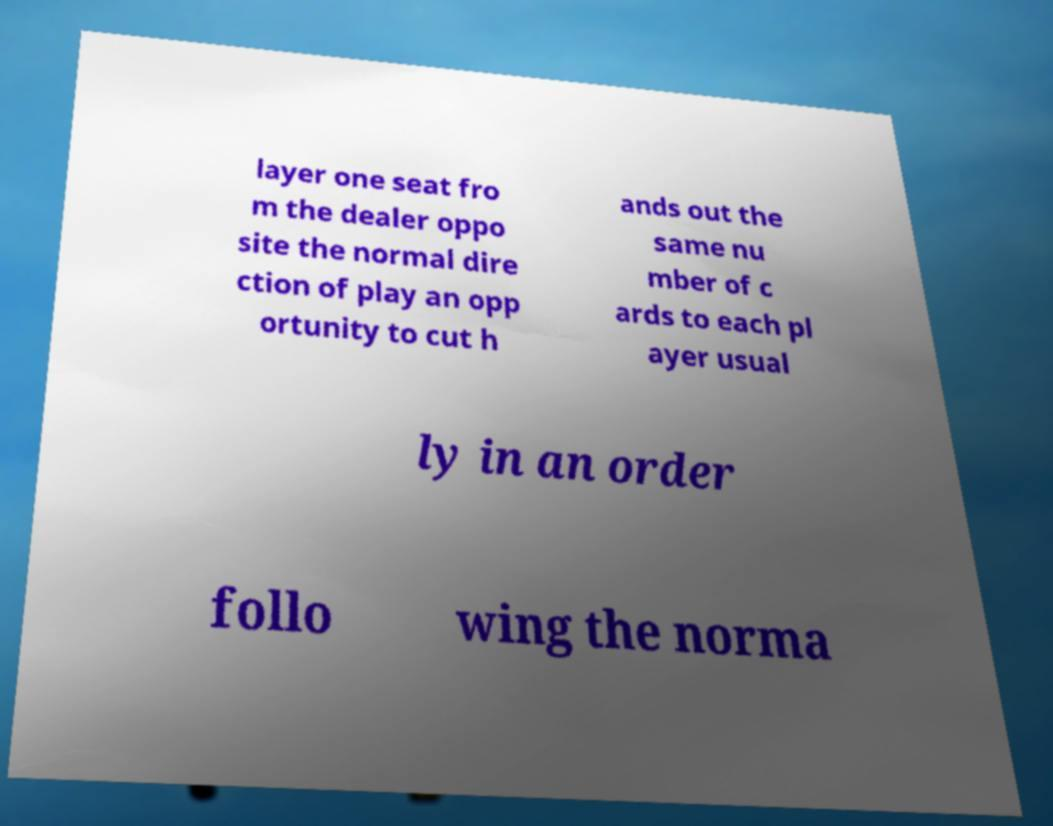Can you read and provide the text displayed in the image?This photo seems to have some interesting text. Can you extract and type it out for me? layer one seat fro m the dealer oppo site the normal dire ction of play an opp ortunity to cut h ands out the same nu mber of c ards to each pl ayer usual ly in an order follo wing the norma 